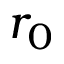Convert formula to latex. <formula><loc_0><loc_0><loc_500><loc_500>r _ { 0 }</formula> 